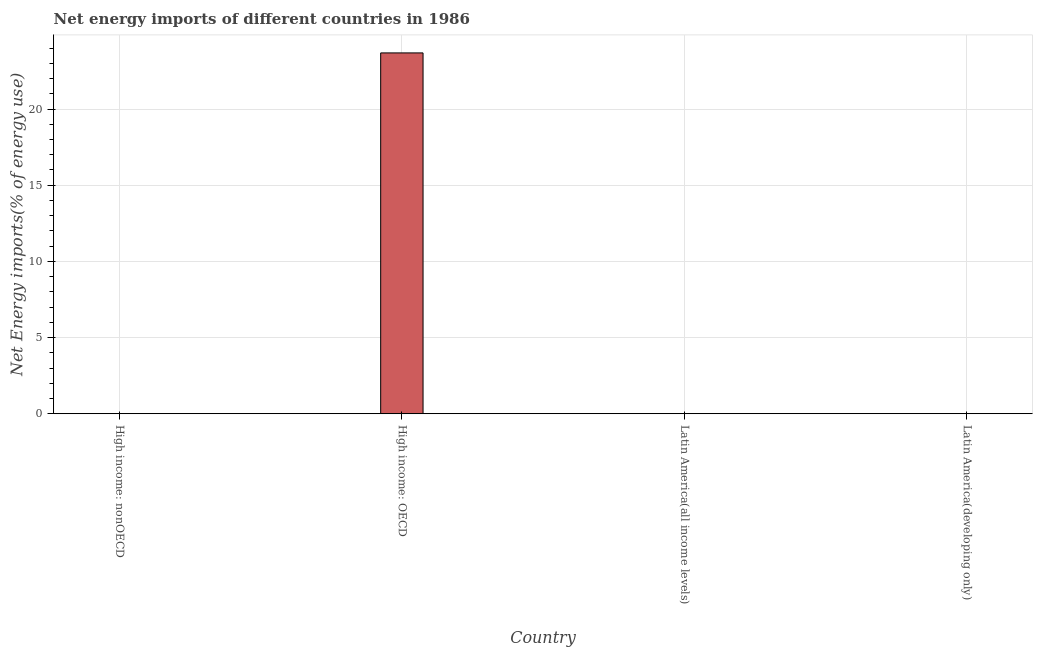Does the graph contain grids?
Ensure brevity in your answer.  Yes. What is the title of the graph?
Offer a very short reply. Net energy imports of different countries in 1986. What is the label or title of the X-axis?
Provide a succinct answer. Country. What is the label or title of the Y-axis?
Ensure brevity in your answer.  Net Energy imports(% of energy use). Across all countries, what is the maximum energy imports?
Your response must be concise. 23.68. Across all countries, what is the minimum energy imports?
Provide a succinct answer. 0. In which country was the energy imports maximum?
Give a very brief answer. High income: OECD. What is the sum of the energy imports?
Give a very brief answer. 23.68. What is the average energy imports per country?
Your response must be concise. 5.92. In how many countries, is the energy imports greater than 19 %?
Keep it short and to the point. 1. What is the difference between the highest and the lowest energy imports?
Give a very brief answer. 23.68. In how many countries, is the energy imports greater than the average energy imports taken over all countries?
Make the answer very short. 1. How many bars are there?
Make the answer very short. 1. How many countries are there in the graph?
Your answer should be compact. 4. What is the difference between two consecutive major ticks on the Y-axis?
Your answer should be compact. 5. What is the Net Energy imports(% of energy use) in High income: nonOECD?
Provide a short and direct response. 0. What is the Net Energy imports(% of energy use) in High income: OECD?
Offer a very short reply. 23.68. What is the Net Energy imports(% of energy use) in Latin America(all income levels)?
Your answer should be compact. 0. What is the Net Energy imports(% of energy use) in Latin America(developing only)?
Your answer should be compact. 0. 